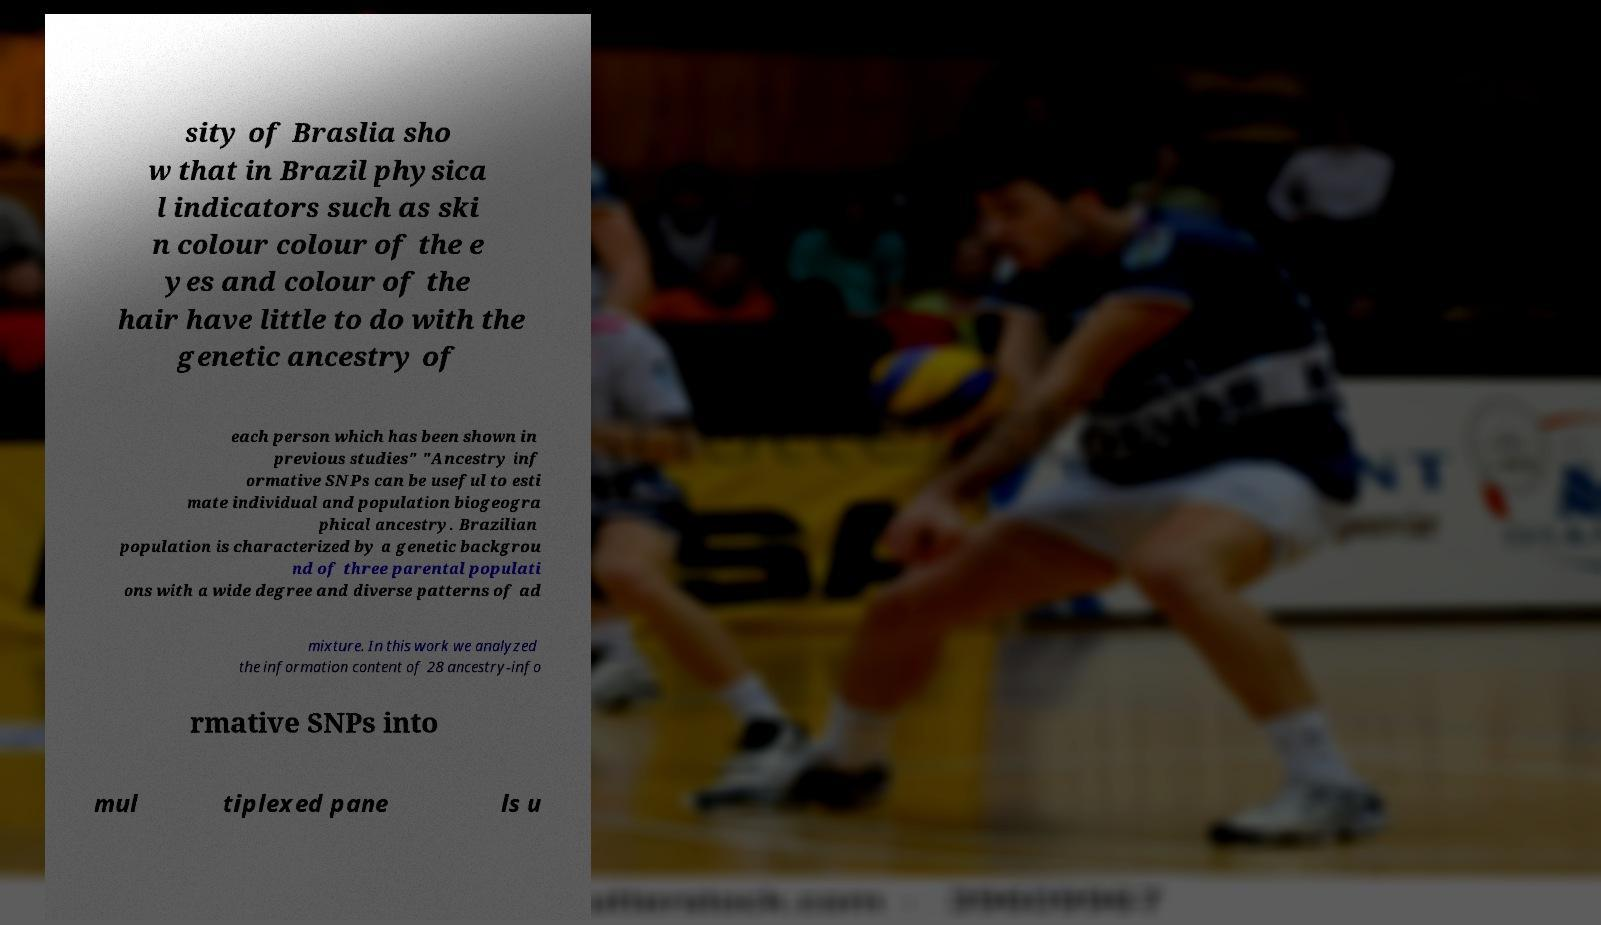Could you extract and type out the text from this image? sity of Braslia sho w that in Brazil physica l indicators such as ski n colour colour of the e yes and colour of the hair have little to do with the genetic ancestry of each person which has been shown in previous studies" "Ancestry inf ormative SNPs can be useful to esti mate individual and population biogeogra phical ancestry. Brazilian population is characterized by a genetic backgrou nd of three parental populati ons with a wide degree and diverse patterns of ad mixture. In this work we analyzed the information content of 28 ancestry-info rmative SNPs into mul tiplexed pane ls u 